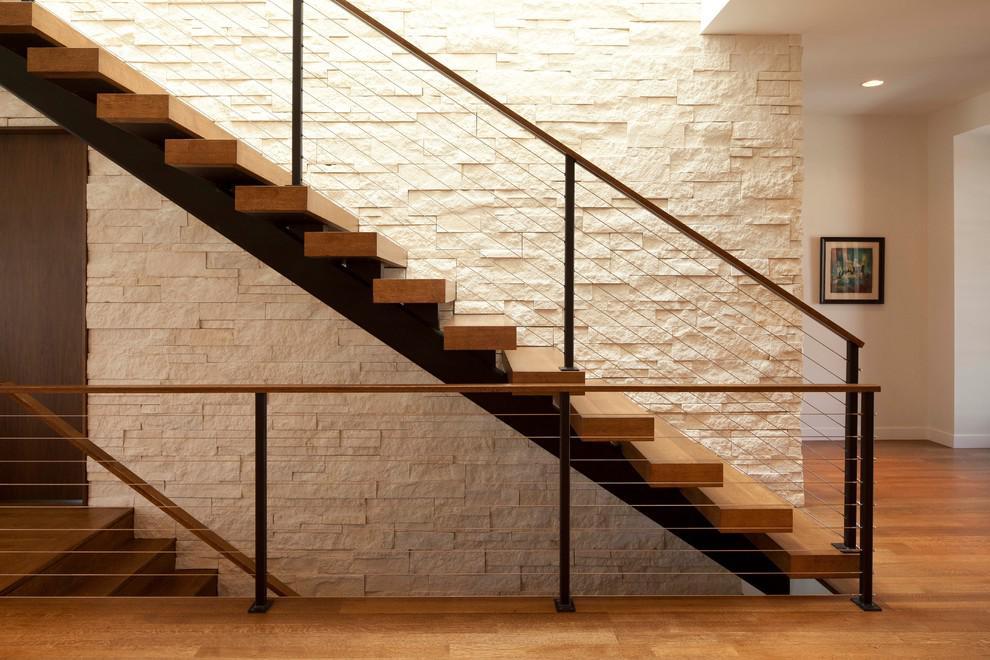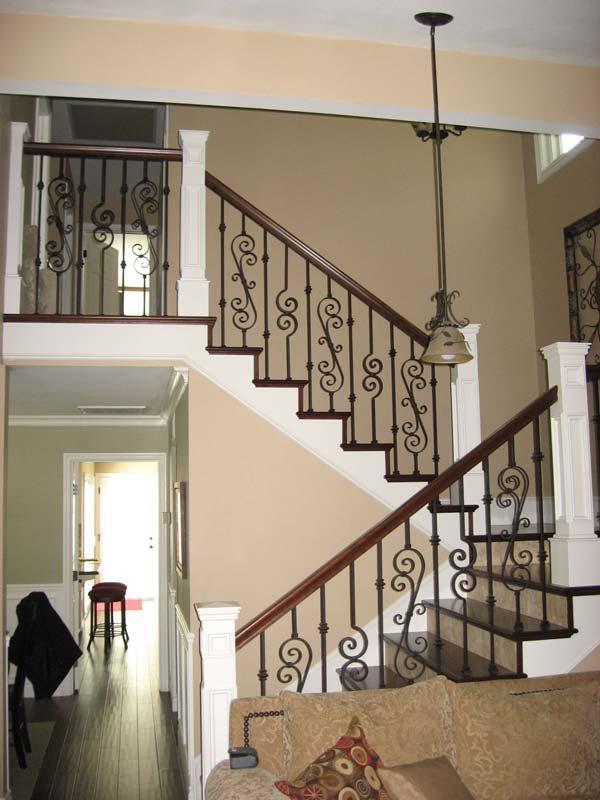The first image is the image on the left, the second image is the image on the right. Given the left and right images, does the statement "In one of the images there is a small door underneath a staircase." hold true? Answer yes or no. No. The first image is the image on the left, the second image is the image on the right. For the images shown, is this caption "An image shows a wooden-railed staircase that ascends rightward before turning, and has black wrought iron vertical bars with S scroll shapes." true? Answer yes or no. Yes. 